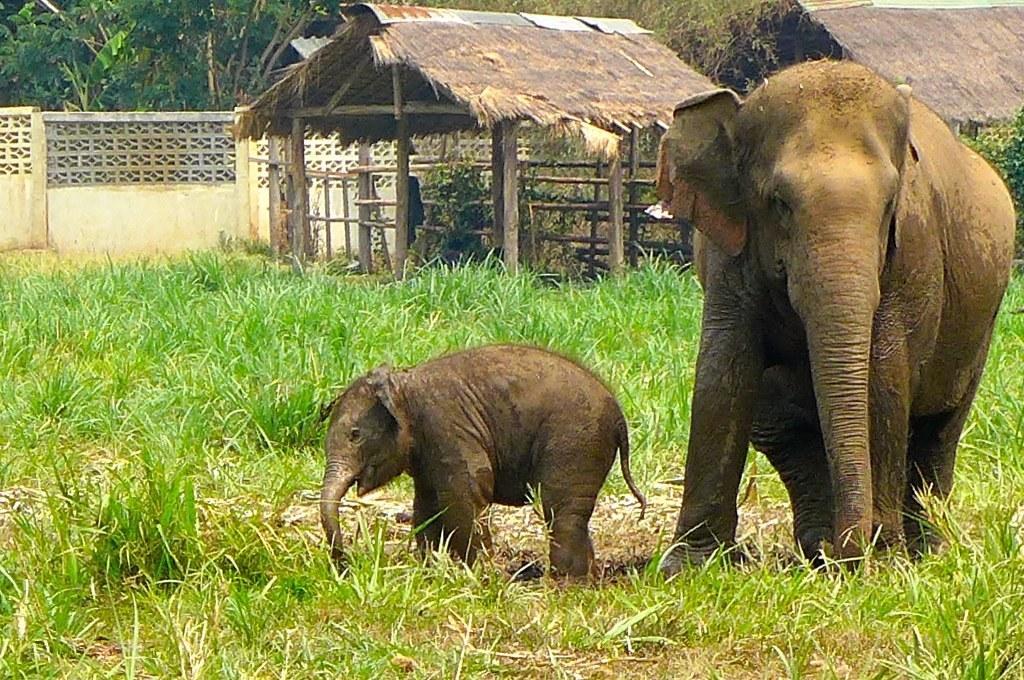In one or two sentences, can you explain what this image depicts? In this picture I can see elephant and its calf and I can see grass on the ground, few trees and couple of huts in the back and I can see a wall. 